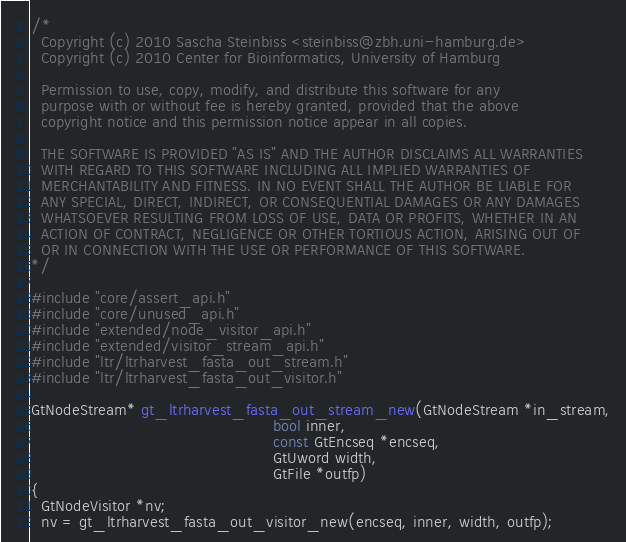<code> <loc_0><loc_0><loc_500><loc_500><_C_>/*
  Copyright (c) 2010 Sascha Steinbiss <steinbiss@zbh.uni-hamburg.de>
  Copyright (c) 2010 Center for Bioinformatics, University of Hamburg

  Permission to use, copy, modify, and distribute this software for any
  purpose with or without fee is hereby granted, provided that the above
  copyright notice and this permission notice appear in all copies.

  THE SOFTWARE IS PROVIDED "AS IS" AND THE AUTHOR DISCLAIMS ALL WARRANTIES
  WITH REGARD TO THIS SOFTWARE INCLUDING ALL IMPLIED WARRANTIES OF
  MERCHANTABILITY AND FITNESS. IN NO EVENT SHALL THE AUTHOR BE LIABLE FOR
  ANY SPECIAL, DIRECT, INDIRECT, OR CONSEQUENTIAL DAMAGES OR ANY DAMAGES
  WHATSOEVER RESULTING FROM LOSS OF USE, DATA OR PROFITS, WHETHER IN AN
  ACTION OF CONTRACT, NEGLIGENCE OR OTHER TORTIOUS ACTION, ARISING OUT OF
  OR IN CONNECTION WITH THE USE OR PERFORMANCE OF THIS SOFTWARE.
*/

#include "core/assert_api.h"
#include "core/unused_api.h"
#include "extended/node_visitor_api.h"
#include "extended/visitor_stream_api.h"
#include "ltr/ltrharvest_fasta_out_stream.h"
#include "ltr/ltrharvest_fasta_out_visitor.h"

GtNodeStream* gt_ltrharvest_fasta_out_stream_new(GtNodeStream *in_stream,
                                                 bool inner,
                                                 const GtEncseq *encseq,
                                                 GtUword width,
                                                 GtFile *outfp)
{
  GtNodeVisitor *nv;
  nv = gt_ltrharvest_fasta_out_visitor_new(encseq, inner, width, outfp);</code> 